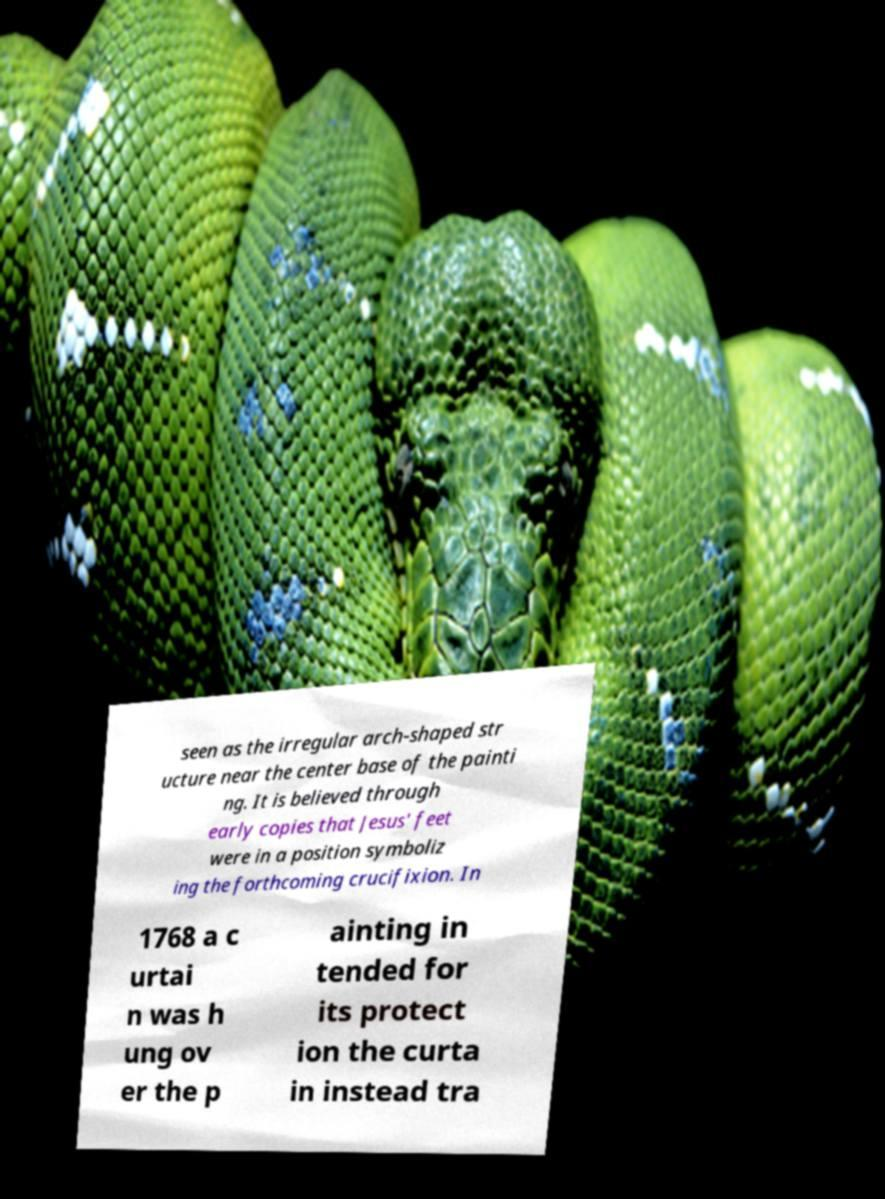Can you read and provide the text displayed in the image?This photo seems to have some interesting text. Can you extract and type it out for me? seen as the irregular arch-shaped str ucture near the center base of the painti ng. It is believed through early copies that Jesus' feet were in a position symboliz ing the forthcoming crucifixion. In 1768 a c urtai n was h ung ov er the p ainting in tended for its protect ion the curta in instead tra 